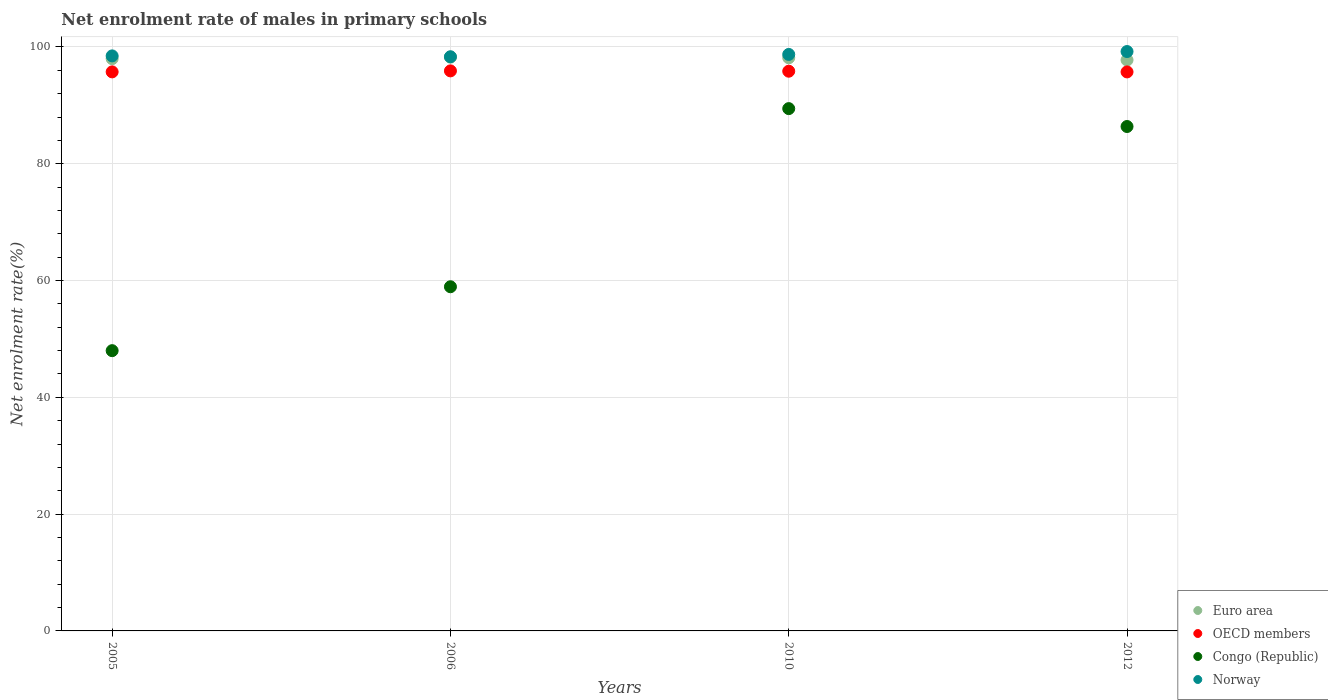What is the net enrolment rate of males in primary schools in Congo (Republic) in 2006?
Provide a succinct answer. 58.94. Across all years, what is the maximum net enrolment rate of males in primary schools in OECD members?
Ensure brevity in your answer.  95.9. Across all years, what is the minimum net enrolment rate of males in primary schools in Euro area?
Your answer should be very brief. 97.77. What is the total net enrolment rate of males in primary schools in Euro area in the graph?
Your answer should be very brief. 392.18. What is the difference between the net enrolment rate of males in primary schools in OECD members in 2005 and that in 2012?
Make the answer very short. 0.01. What is the difference between the net enrolment rate of males in primary schools in Norway in 2006 and the net enrolment rate of males in primary schools in Euro area in 2010?
Provide a short and direct response. 0.17. What is the average net enrolment rate of males in primary schools in Norway per year?
Your response must be concise. 98.68. In the year 2006, what is the difference between the net enrolment rate of males in primary schools in Euro area and net enrolment rate of males in primary schools in Congo (Republic)?
Provide a succinct answer. 39.32. In how many years, is the net enrolment rate of males in primary schools in Congo (Republic) greater than 40 %?
Make the answer very short. 4. What is the ratio of the net enrolment rate of males in primary schools in Euro area in 2005 to that in 2012?
Provide a short and direct response. 1. Is the net enrolment rate of males in primary schools in Congo (Republic) in 2005 less than that in 2006?
Keep it short and to the point. Yes. What is the difference between the highest and the second highest net enrolment rate of males in primary schools in Norway?
Provide a succinct answer. 0.5. What is the difference between the highest and the lowest net enrolment rate of males in primary schools in Congo (Republic)?
Give a very brief answer. 41.45. Is the net enrolment rate of males in primary schools in Norway strictly greater than the net enrolment rate of males in primary schools in Euro area over the years?
Your answer should be compact. Yes. Is the net enrolment rate of males in primary schools in Euro area strictly less than the net enrolment rate of males in primary schools in Norway over the years?
Offer a very short reply. Yes. How many dotlines are there?
Offer a very short reply. 4. Are the values on the major ticks of Y-axis written in scientific E-notation?
Offer a terse response. No. Does the graph contain any zero values?
Make the answer very short. No. Does the graph contain grids?
Provide a succinct answer. Yes. Where does the legend appear in the graph?
Keep it short and to the point. Bottom right. How many legend labels are there?
Provide a short and direct response. 4. What is the title of the graph?
Provide a short and direct response. Net enrolment rate of males in primary schools. Does "Somalia" appear as one of the legend labels in the graph?
Keep it short and to the point. No. What is the label or title of the Y-axis?
Your response must be concise. Net enrolment rate(%). What is the Net enrolment rate(%) of Euro area in 2005?
Your answer should be very brief. 98. What is the Net enrolment rate(%) of OECD members in 2005?
Your response must be concise. 95.73. What is the Net enrolment rate(%) of Congo (Republic) in 2005?
Provide a short and direct response. 47.99. What is the Net enrolment rate(%) of Norway in 2005?
Provide a short and direct response. 98.47. What is the Net enrolment rate(%) in Euro area in 2006?
Ensure brevity in your answer.  98.26. What is the Net enrolment rate(%) of OECD members in 2006?
Your answer should be compact. 95.9. What is the Net enrolment rate(%) of Congo (Republic) in 2006?
Ensure brevity in your answer.  58.94. What is the Net enrolment rate(%) of Norway in 2006?
Give a very brief answer. 98.32. What is the Net enrolment rate(%) in Euro area in 2010?
Provide a short and direct response. 98.15. What is the Net enrolment rate(%) in OECD members in 2010?
Provide a succinct answer. 95.85. What is the Net enrolment rate(%) of Congo (Republic) in 2010?
Provide a succinct answer. 89.44. What is the Net enrolment rate(%) in Norway in 2010?
Offer a terse response. 98.72. What is the Net enrolment rate(%) in Euro area in 2012?
Offer a very short reply. 97.77. What is the Net enrolment rate(%) in OECD members in 2012?
Give a very brief answer. 95.73. What is the Net enrolment rate(%) of Congo (Republic) in 2012?
Give a very brief answer. 86.38. What is the Net enrolment rate(%) of Norway in 2012?
Provide a short and direct response. 99.22. Across all years, what is the maximum Net enrolment rate(%) in Euro area?
Make the answer very short. 98.26. Across all years, what is the maximum Net enrolment rate(%) of OECD members?
Ensure brevity in your answer.  95.9. Across all years, what is the maximum Net enrolment rate(%) in Congo (Republic)?
Your answer should be compact. 89.44. Across all years, what is the maximum Net enrolment rate(%) of Norway?
Your answer should be compact. 99.22. Across all years, what is the minimum Net enrolment rate(%) of Euro area?
Your answer should be compact. 97.77. Across all years, what is the minimum Net enrolment rate(%) in OECD members?
Keep it short and to the point. 95.73. Across all years, what is the minimum Net enrolment rate(%) of Congo (Republic)?
Make the answer very short. 47.99. Across all years, what is the minimum Net enrolment rate(%) of Norway?
Ensure brevity in your answer.  98.32. What is the total Net enrolment rate(%) in Euro area in the graph?
Provide a succinct answer. 392.18. What is the total Net enrolment rate(%) of OECD members in the graph?
Provide a short and direct response. 383.21. What is the total Net enrolment rate(%) in Congo (Republic) in the graph?
Offer a terse response. 282.75. What is the total Net enrolment rate(%) in Norway in the graph?
Ensure brevity in your answer.  394.74. What is the difference between the Net enrolment rate(%) in Euro area in 2005 and that in 2006?
Make the answer very short. -0.26. What is the difference between the Net enrolment rate(%) in OECD members in 2005 and that in 2006?
Offer a terse response. -0.17. What is the difference between the Net enrolment rate(%) in Congo (Republic) in 2005 and that in 2006?
Your answer should be compact. -10.94. What is the difference between the Net enrolment rate(%) of Norway in 2005 and that in 2006?
Ensure brevity in your answer.  0.15. What is the difference between the Net enrolment rate(%) in Euro area in 2005 and that in 2010?
Ensure brevity in your answer.  -0.15. What is the difference between the Net enrolment rate(%) of OECD members in 2005 and that in 2010?
Your answer should be compact. -0.12. What is the difference between the Net enrolment rate(%) of Congo (Republic) in 2005 and that in 2010?
Keep it short and to the point. -41.45. What is the difference between the Net enrolment rate(%) of Norway in 2005 and that in 2010?
Provide a short and direct response. -0.25. What is the difference between the Net enrolment rate(%) of Euro area in 2005 and that in 2012?
Provide a short and direct response. 0.23. What is the difference between the Net enrolment rate(%) of OECD members in 2005 and that in 2012?
Make the answer very short. 0.01. What is the difference between the Net enrolment rate(%) in Congo (Republic) in 2005 and that in 2012?
Offer a very short reply. -38.39. What is the difference between the Net enrolment rate(%) in Norway in 2005 and that in 2012?
Keep it short and to the point. -0.75. What is the difference between the Net enrolment rate(%) of Euro area in 2006 and that in 2010?
Your answer should be compact. 0.11. What is the difference between the Net enrolment rate(%) of OECD members in 2006 and that in 2010?
Offer a terse response. 0.06. What is the difference between the Net enrolment rate(%) in Congo (Republic) in 2006 and that in 2010?
Make the answer very short. -30.5. What is the difference between the Net enrolment rate(%) in Norway in 2006 and that in 2010?
Your answer should be very brief. -0.4. What is the difference between the Net enrolment rate(%) of Euro area in 2006 and that in 2012?
Provide a short and direct response. 0.49. What is the difference between the Net enrolment rate(%) in OECD members in 2006 and that in 2012?
Your response must be concise. 0.18. What is the difference between the Net enrolment rate(%) in Congo (Republic) in 2006 and that in 2012?
Your response must be concise. -27.44. What is the difference between the Net enrolment rate(%) in Norway in 2006 and that in 2012?
Provide a short and direct response. -0.9. What is the difference between the Net enrolment rate(%) of Euro area in 2010 and that in 2012?
Make the answer very short. 0.38. What is the difference between the Net enrolment rate(%) of OECD members in 2010 and that in 2012?
Keep it short and to the point. 0.12. What is the difference between the Net enrolment rate(%) of Congo (Republic) in 2010 and that in 2012?
Your answer should be compact. 3.06. What is the difference between the Net enrolment rate(%) in Norway in 2010 and that in 2012?
Give a very brief answer. -0.5. What is the difference between the Net enrolment rate(%) of Euro area in 2005 and the Net enrolment rate(%) of OECD members in 2006?
Ensure brevity in your answer.  2.09. What is the difference between the Net enrolment rate(%) in Euro area in 2005 and the Net enrolment rate(%) in Congo (Republic) in 2006?
Your response must be concise. 39.06. What is the difference between the Net enrolment rate(%) of Euro area in 2005 and the Net enrolment rate(%) of Norway in 2006?
Keep it short and to the point. -0.33. What is the difference between the Net enrolment rate(%) of OECD members in 2005 and the Net enrolment rate(%) of Congo (Republic) in 2006?
Ensure brevity in your answer.  36.79. What is the difference between the Net enrolment rate(%) in OECD members in 2005 and the Net enrolment rate(%) in Norway in 2006?
Offer a terse response. -2.59. What is the difference between the Net enrolment rate(%) in Congo (Republic) in 2005 and the Net enrolment rate(%) in Norway in 2006?
Make the answer very short. -50.33. What is the difference between the Net enrolment rate(%) in Euro area in 2005 and the Net enrolment rate(%) in OECD members in 2010?
Give a very brief answer. 2.15. What is the difference between the Net enrolment rate(%) of Euro area in 2005 and the Net enrolment rate(%) of Congo (Republic) in 2010?
Provide a short and direct response. 8.55. What is the difference between the Net enrolment rate(%) of Euro area in 2005 and the Net enrolment rate(%) of Norway in 2010?
Your answer should be compact. -0.73. What is the difference between the Net enrolment rate(%) of OECD members in 2005 and the Net enrolment rate(%) of Congo (Republic) in 2010?
Offer a very short reply. 6.29. What is the difference between the Net enrolment rate(%) of OECD members in 2005 and the Net enrolment rate(%) of Norway in 2010?
Your response must be concise. -2.99. What is the difference between the Net enrolment rate(%) of Congo (Republic) in 2005 and the Net enrolment rate(%) of Norway in 2010?
Provide a short and direct response. -50.73. What is the difference between the Net enrolment rate(%) in Euro area in 2005 and the Net enrolment rate(%) in OECD members in 2012?
Your response must be concise. 2.27. What is the difference between the Net enrolment rate(%) of Euro area in 2005 and the Net enrolment rate(%) of Congo (Republic) in 2012?
Provide a short and direct response. 11.62. What is the difference between the Net enrolment rate(%) in Euro area in 2005 and the Net enrolment rate(%) in Norway in 2012?
Give a very brief answer. -1.22. What is the difference between the Net enrolment rate(%) of OECD members in 2005 and the Net enrolment rate(%) of Congo (Republic) in 2012?
Keep it short and to the point. 9.35. What is the difference between the Net enrolment rate(%) of OECD members in 2005 and the Net enrolment rate(%) of Norway in 2012?
Offer a very short reply. -3.49. What is the difference between the Net enrolment rate(%) in Congo (Republic) in 2005 and the Net enrolment rate(%) in Norway in 2012?
Your response must be concise. -51.23. What is the difference between the Net enrolment rate(%) of Euro area in 2006 and the Net enrolment rate(%) of OECD members in 2010?
Offer a very short reply. 2.41. What is the difference between the Net enrolment rate(%) of Euro area in 2006 and the Net enrolment rate(%) of Congo (Republic) in 2010?
Your response must be concise. 8.82. What is the difference between the Net enrolment rate(%) in Euro area in 2006 and the Net enrolment rate(%) in Norway in 2010?
Offer a very short reply. -0.46. What is the difference between the Net enrolment rate(%) of OECD members in 2006 and the Net enrolment rate(%) of Congo (Republic) in 2010?
Give a very brief answer. 6.46. What is the difference between the Net enrolment rate(%) of OECD members in 2006 and the Net enrolment rate(%) of Norway in 2010?
Your answer should be very brief. -2.82. What is the difference between the Net enrolment rate(%) in Congo (Republic) in 2006 and the Net enrolment rate(%) in Norway in 2010?
Provide a succinct answer. -39.78. What is the difference between the Net enrolment rate(%) of Euro area in 2006 and the Net enrolment rate(%) of OECD members in 2012?
Your response must be concise. 2.53. What is the difference between the Net enrolment rate(%) in Euro area in 2006 and the Net enrolment rate(%) in Congo (Republic) in 2012?
Your answer should be very brief. 11.88. What is the difference between the Net enrolment rate(%) in Euro area in 2006 and the Net enrolment rate(%) in Norway in 2012?
Give a very brief answer. -0.96. What is the difference between the Net enrolment rate(%) in OECD members in 2006 and the Net enrolment rate(%) in Congo (Republic) in 2012?
Offer a very short reply. 9.53. What is the difference between the Net enrolment rate(%) of OECD members in 2006 and the Net enrolment rate(%) of Norway in 2012?
Your answer should be very brief. -3.31. What is the difference between the Net enrolment rate(%) of Congo (Republic) in 2006 and the Net enrolment rate(%) of Norway in 2012?
Offer a very short reply. -40.28. What is the difference between the Net enrolment rate(%) of Euro area in 2010 and the Net enrolment rate(%) of OECD members in 2012?
Offer a terse response. 2.42. What is the difference between the Net enrolment rate(%) of Euro area in 2010 and the Net enrolment rate(%) of Congo (Republic) in 2012?
Your answer should be compact. 11.77. What is the difference between the Net enrolment rate(%) in Euro area in 2010 and the Net enrolment rate(%) in Norway in 2012?
Provide a short and direct response. -1.07. What is the difference between the Net enrolment rate(%) of OECD members in 2010 and the Net enrolment rate(%) of Congo (Republic) in 2012?
Give a very brief answer. 9.47. What is the difference between the Net enrolment rate(%) in OECD members in 2010 and the Net enrolment rate(%) in Norway in 2012?
Provide a short and direct response. -3.37. What is the difference between the Net enrolment rate(%) of Congo (Republic) in 2010 and the Net enrolment rate(%) of Norway in 2012?
Offer a terse response. -9.78. What is the average Net enrolment rate(%) in Euro area per year?
Make the answer very short. 98.04. What is the average Net enrolment rate(%) in OECD members per year?
Give a very brief answer. 95.8. What is the average Net enrolment rate(%) in Congo (Republic) per year?
Keep it short and to the point. 70.69. What is the average Net enrolment rate(%) of Norway per year?
Offer a very short reply. 98.68. In the year 2005, what is the difference between the Net enrolment rate(%) in Euro area and Net enrolment rate(%) in OECD members?
Keep it short and to the point. 2.26. In the year 2005, what is the difference between the Net enrolment rate(%) of Euro area and Net enrolment rate(%) of Congo (Republic)?
Make the answer very short. 50. In the year 2005, what is the difference between the Net enrolment rate(%) in Euro area and Net enrolment rate(%) in Norway?
Ensure brevity in your answer.  -0.47. In the year 2005, what is the difference between the Net enrolment rate(%) of OECD members and Net enrolment rate(%) of Congo (Republic)?
Offer a very short reply. 47.74. In the year 2005, what is the difference between the Net enrolment rate(%) of OECD members and Net enrolment rate(%) of Norway?
Offer a terse response. -2.74. In the year 2005, what is the difference between the Net enrolment rate(%) of Congo (Republic) and Net enrolment rate(%) of Norway?
Keep it short and to the point. -50.48. In the year 2006, what is the difference between the Net enrolment rate(%) in Euro area and Net enrolment rate(%) in OECD members?
Keep it short and to the point. 2.36. In the year 2006, what is the difference between the Net enrolment rate(%) of Euro area and Net enrolment rate(%) of Congo (Republic)?
Make the answer very short. 39.32. In the year 2006, what is the difference between the Net enrolment rate(%) in Euro area and Net enrolment rate(%) in Norway?
Make the answer very short. -0.06. In the year 2006, what is the difference between the Net enrolment rate(%) of OECD members and Net enrolment rate(%) of Congo (Republic)?
Provide a succinct answer. 36.97. In the year 2006, what is the difference between the Net enrolment rate(%) of OECD members and Net enrolment rate(%) of Norway?
Your answer should be very brief. -2.42. In the year 2006, what is the difference between the Net enrolment rate(%) in Congo (Republic) and Net enrolment rate(%) in Norway?
Ensure brevity in your answer.  -39.39. In the year 2010, what is the difference between the Net enrolment rate(%) of Euro area and Net enrolment rate(%) of Congo (Republic)?
Offer a very short reply. 8.71. In the year 2010, what is the difference between the Net enrolment rate(%) in Euro area and Net enrolment rate(%) in Norway?
Ensure brevity in your answer.  -0.57. In the year 2010, what is the difference between the Net enrolment rate(%) in OECD members and Net enrolment rate(%) in Congo (Republic)?
Provide a short and direct response. 6.41. In the year 2010, what is the difference between the Net enrolment rate(%) in OECD members and Net enrolment rate(%) in Norway?
Your answer should be very brief. -2.87. In the year 2010, what is the difference between the Net enrolment rate(%) of Congo (Republic) and Net enrolment rate(%) of Norway?
Give a very brief answer. -9.28. In the year 2012, what is the difference between the Net enrolment rate(%) of Euro area and Net enrolment rate(%) of OECD members?
Your answer should be compact. 2.04. In the year 2012, what is the difference between the Net enrolment rate(%) in Euro area and Net enrolment rate(%) in Congo (Republic)?
Give a very brief answer. 11.39. In the year 2012, what is the difference between the Net enrolment rate(%) in Euro area and Net enrolment rate(%) in Norway?
Provide a succinct answer. -1.45. In the year 2012, what is the difference between the Net enrolment rate(%) of OECD members and Net enrolment rate(%) of Congo (Republic)?
Give a very brief answer. 9.35. In the year 2012, what is the difference between the Net enrolment rate(%) of OECD members and Net enrolment rate(%) of Norway?
Provide a succinct answer. -3.49. In the year 2012, what is the difference between the Net enrolment rate(%) of Congo (Republic) and Net enrolment rate(%) of Norway?
Your answer should be compact. -12.84. What is the ratio of the Net enrolment rate(%) of Euro area in 2005 to that in 2006?
Ensure brevity in your answer.  1. What is the ratio of the Net enrolment rate(%) of Congo (Republic) in 2005 to that in 2006?
Offer a very short reply. 0.81. What is the ratio of the Net enrolment rate(%) in Euro area in 2005 to that in 2010?
Make the answer very short. 1. What is the ratio of the Net enrolment rate(%) of Congo (Republic) in 2005 to that in 2010?
Your response must be concise. 0.54. What is the ratio of the Net enrolment rate(%) in Norway in 2005 to that in 2010?
Ensure brevity in your answer.  1. What is the ratio of the Net enrolment rate(%) in Euro area in 2005 to that in 2012?
Keep it short and to the point. 1. What is the ratio of the Net enrolment rate(%) in OECD members in 2005 to that in 2012?
Provide a short and direct response. 1. What is the ratio of the Net enrolment rate(%) of Congo (Republic) in 2005 to that in 2012?
Ensure brevity in your answer.  0.56. What is the ratio of the Net enrolment rate(%) in OECD members in 2006 to that in 2010?
Your response must be concise. 1. What is the ratio of the Net enrolment rate(%) of Congo (Republic) in 2006 to that in 2010?
Offer a very short reply. 0.66. What is the ratio of the Net enrolment rate(%) of Norway in 2006 to that in 2010?
Keep it short and to the point. 1. What is the ratio of the Net enrolment rate(%) of Congo (Republic) in 2006 to that in 2012?
Make the answer very short. 0.68. What is the ratio of the Net enrolment rate(%) of Norway in 2006 to that in 2012?
Ensure brevity in your answer.  0.99. What is the ratio of the Net enrolment rate(%) of Euro area in 2010 to that in 2012?
Keep it short and to the point. 1. What is the ratio of the Net enrolment rate(%) in Congo (Republic) in 2010 to that in 2012?
Make the answer very short. 1.04. What is the ratio of the Net enrolment rate(%) in Norway in 2010 to that in 2012?
Provide a short and direct response. 0.99. What is the difference between the highest and the second highest Net enrolment rate(%) in Euro area?
Make the answer very short. 0.11. What is the difference between the highest and the second highest Net enrolment rate(%) in OECD members?
Make the answer very short. 0.06. What is the difference between the highest and the second highest Net enrolment rate(%) in Congo (Republic)?
Make the answer very short. 3.06. What is the difference between the highest and the second highest Net enrolment rate(%) of Norway?
Make the answer very short. 0.5. What is the difference between the highest and the lowest Net enrolment rate(%) of Euro area?
Make the answer very short. 0.49. What is the difference between the highest and the lowest Net enrolment rate(%) in OECD members?
Your answer should be compact. 0.18. What is the difference between the highest and the lowest Net enrolment rate(%) of Congo (Republic)?
Your answer should be compact. 41.45. What is the difference between the highest and the lowest Net enrolment rate(%) of Norway?
Offer a very short reply. 0.9. 